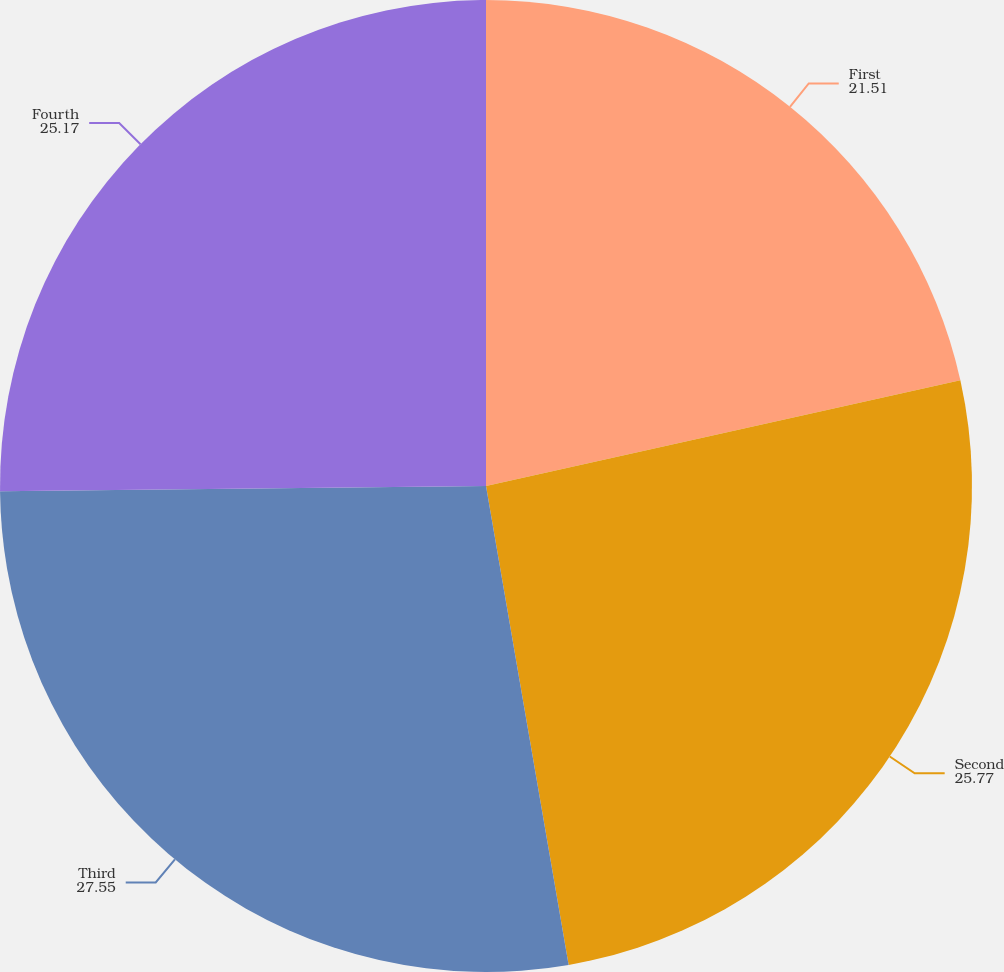Convert chart. <chart><loc_0><loc_0><loc_500><loc_500><pie_chart><fcel>First<fcel>Second<fcel>Third<fcel>Fourth<nl><fcel>21.51%<fcel>25.77%<fcel>27.55%<fcel>25.17%<nl></chart> 